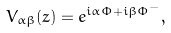<formula> <loc_0><loc_0><loc_500><loc_500>V _ { \alpha \beta } ( z ) = e ^ { i \alpha \Phi + i \beta \Phi ^ { - } } ,</formula> 